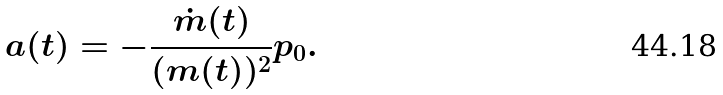Convert formula to latex. <formula><loc_0><loc_0><loc_500><loc_500>a ( t ) = - \frac { \dot { m } ( t ) } { ( m ( t ) ) ^ { 2 } } p _ { 0 } .</formula> 